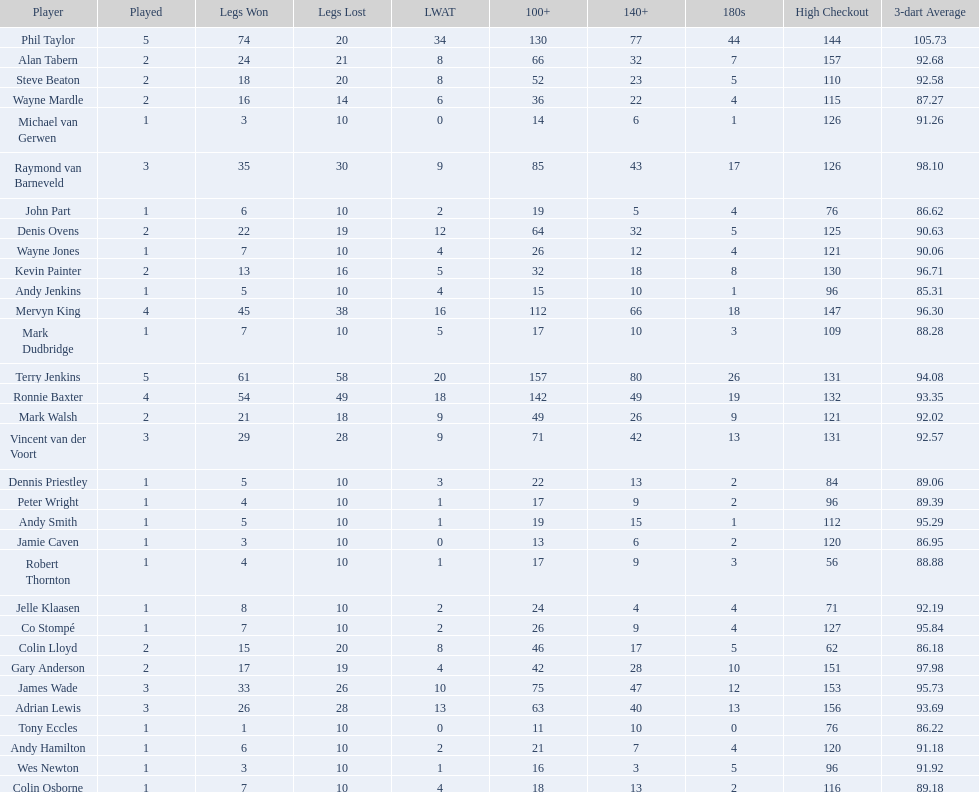Which player lost the least? Co Stompé, Andy Smith, Jelle Klaasen, Wes Newton, Michael van Gerwen, Andy Hamilton, Wayne Jones, Peter Wright, Colin Osborne, Dennis Priestley, Robert Thornton, Mark Dudbridge, Jamie Caven, John Part, Tony Eccles, Andy Jenkins. 